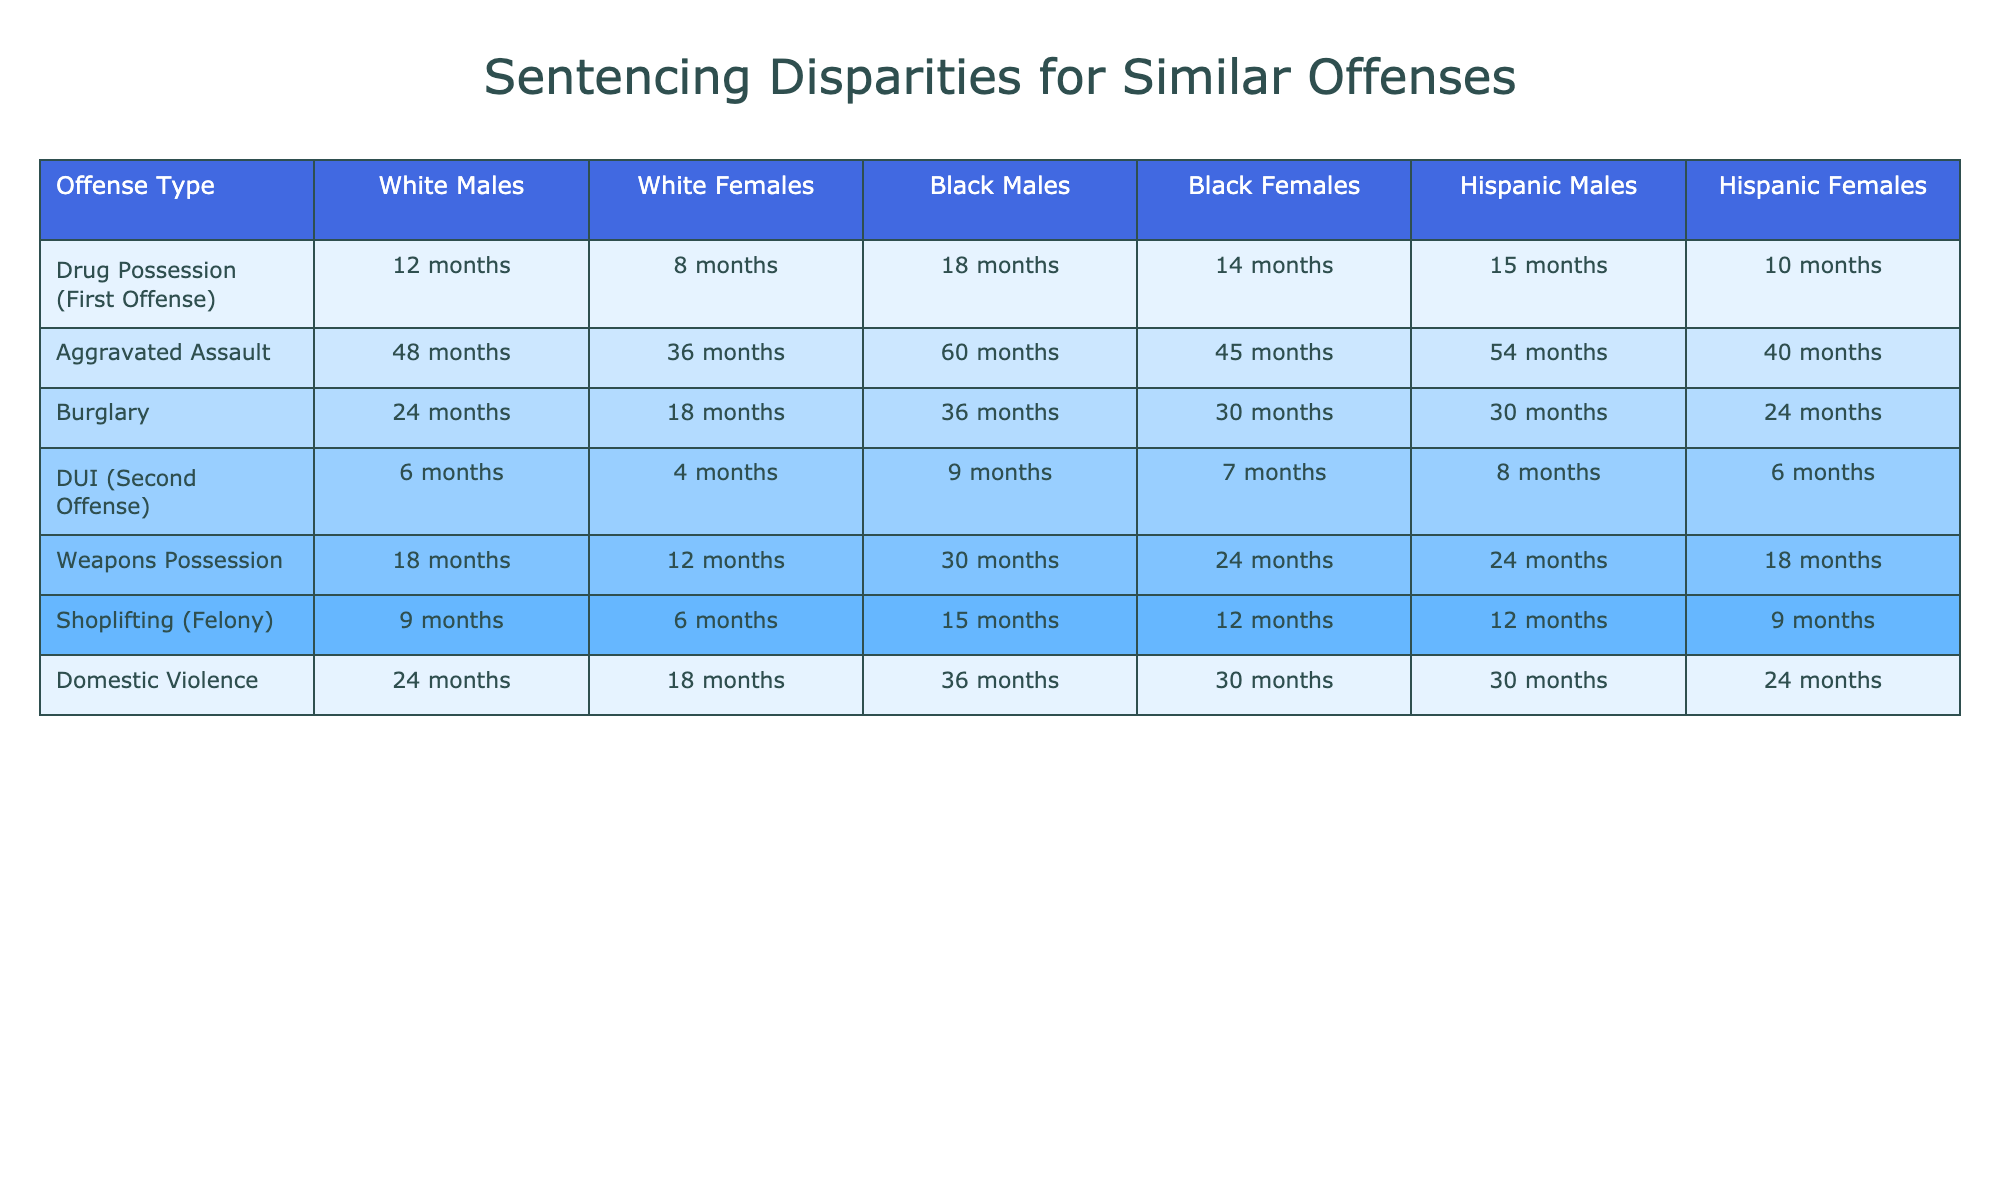What is the sentencing duration for White Males for Drug Possession (First Offense)? The table shows that the sentencing duration for White Males for Drug Possession (First Offense) is 12 months.
Answer: 12 months Which demographic group receives the longest sentence for Aggravated Assault? By comparing the values in the Aggravated Assault row, Black Males have the longest sentence at 60 months.
Answer: Black Males What is the average sentencing duration for Hispanic Females across all offenses listed? The sentencing durations for Hispanic Females are 10 months (Drug Possession), 40 months (Aggravated Assault), 24 months (Burglary), 6 months (DUI), 18 months (Weapons Possession), 9 months (Shoplifting), and 24 months (Domestic Violence). Summing these equals 127 months, and dividing by 7 gives an average of approximately 18.14 months.
Answer: 18.14 months Are women generally sentenced to shorter durations than men for the same offenses? By comparing the lengths in the table, it can be observed that White Females, Black Females, and Hispanic Females generally have shorter sentences than their male counterparts for each corresponding offense, indicating that the statement is true.
Answer: Yes What is the difference in sentencing duration between Black Males and Hispanic Males for Shoplifting (Felony)? The table shows that Black Males receive 15 months, while Hispanic Males receive 12 months for Shoplifting (Felony). The difference is calculated by subtracting 12 from 15, which equals 3 months.
Answer: 3 months Considering only the first offenses, which demographic group has the highest average sentencing duration? For Drug Possession (First Offense), the average for White Males is 12 months, White Females is 8 months, Black Males is 18 months, Black Females is 14 months, Hispanic Males is 15 months, and Hispanic Females is 10 months. The highest average is from Black Males at 18 months.
Answer: Black Males What is the total sentencing duration for all groups combined in the DUI (Second Offense)? Adding the sentencing durations in the DUI row gives: 6 (White Males) + 4 (White Females) + 9 (Black Males) + 7 (Black Females) + 8 (Hispanic Males) + 6 (Hispanic Females) = 40 months total.
Answer: 40 months Which offense has the smallest gap between the minimum and maximum sentencing duration among all demographic groups? Reviewing the table, Drug Possession (First Offense) shows a duration of 8 months for White Females (minimum) and 18 months for Black Males (maximum), which gives a gap of 10 months. Comparing gaps of other offenses reveals no smaller gap than 10 months, thus it is the smallest.
Answer: Drug Possession (First Offense) Do Hispanic Females receive lighter sentences compared to White Females for Burglary? The table indicates that Hispanic Females receive 24 months while White Females receive 18 months for Burglary, thus Hispanic Females actually receive a longer sentence, making the statement false.
Answer: No 